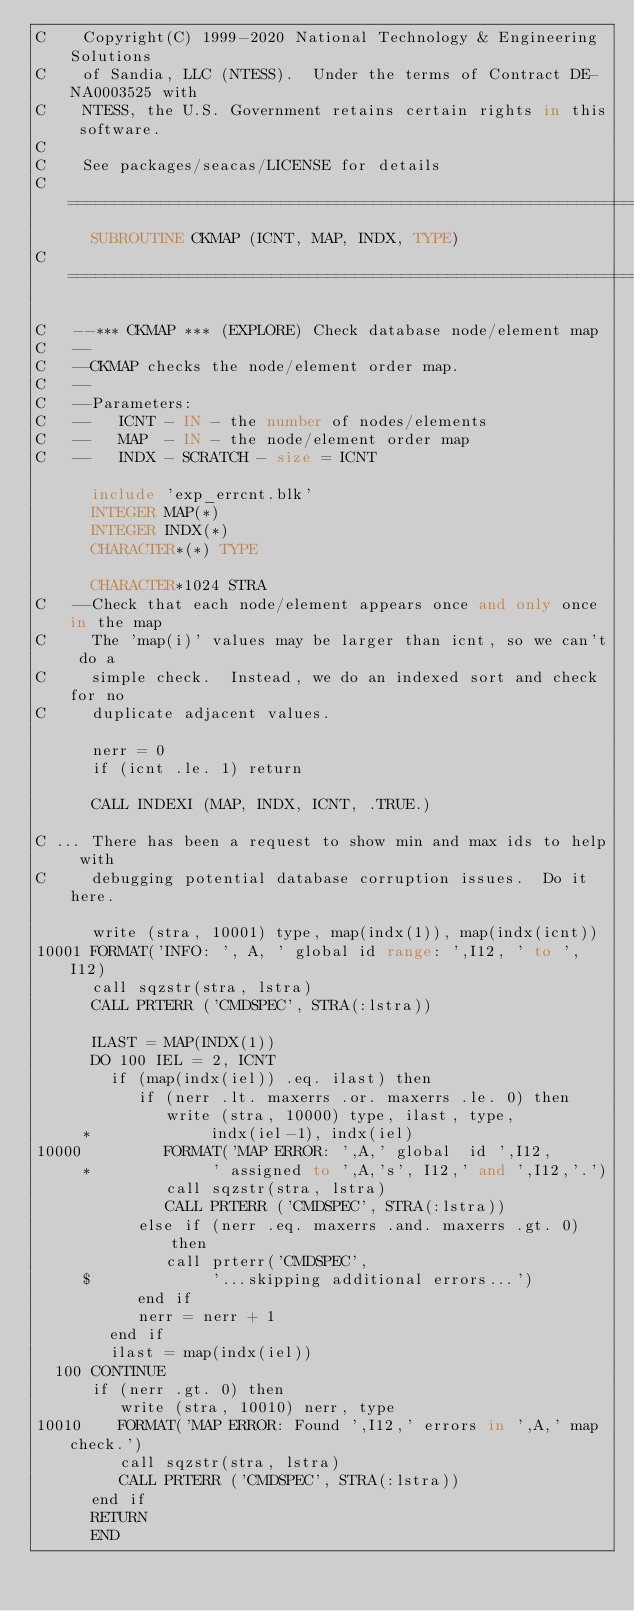<code> <loc_0><loc_0><loc_500><loc_500><_FORTRAN_>C    Copyright(C) 1999-2020 National Technology & Engineering Solutions
C    of Sandia, LLC (NTESS).  Under the terms of Contract DE-NA0003525 with
C    NTESS, the U.S. Government retains certain rights in this software.
C
C    See packages/seacas/LICENSE for details
C=======================================================================
      SUBROUTINE CKMAP (ICNT, MAP, INDX, TYPE)
C=======================================================================

C   --*** CKMAP *** (EXPLORE) Check database node/element map
C   --
C   --CKMAP checks the node/element order map.
C   --
C   --Parameters:
C   --   ICNT - IN - the number of nodes/elements
C   --   MAP  - IN - the node/element order map
C   --   INDX - SCRATCH - size = ICNT

      include 'exp_errcnt.blk'
      INTEGER MAP(*)
      INTEGER INDX(*)
      CHARACTER*(*) TYPE

      CHARACTER*1024 STRA
C   --Check that each node/element appears once and only once in the map
C     The 'map(i)' values may be larger than icnt, so we can't do a
C     simple check.  Instead, we do an indexed sort and check for no
C     duplicate adjacent values.

      nerr = 0
      if (icnt .le. 1) return

      CALL INDEXI (MAP, INDX, ICNT, .TRUE.)

C ... There has been a request to show min and max ids to help with
C     debugging potential database corruption issues.  Do it here.

      write (stra, 10001) type, map(indx(1)), map(indx(icnt))
10001 FORMAT('INFO: ', A, ' global id range: ',I12, ' to ', I12)
      call sqzstr(stra, lstra)
      CALL PRTERR ('CMDSPEC', STRA(:lstra))

      ILAST = MAP(INDX(1))
      DO 100 IEL = 2, ICNT
        if (map(indx(iel)) .eq. ilast) then
           if (nerr .lt. maxerrs .or. maxerrs .le. 0) then
              write (stra, 10000) type, ilast, type,
     *             indx(iel-1), indx(iel)
10000         FORMAT('MAP ERROR: ',A,' global  id ',I12,
     *             ' assigned to ',A,'s', I12,' and ',I12,'.')
              call sqzstr(stra, lstra)
              CALL PRTERR ('CMDSPEC', STRA(:lstra))
           else if (nerr .eq. maxerrs .and. maxerrs .gt. 0) then
              call prterr('CMDSPEC',
     $             '...skipping additional errors...')
           end if
           nerr = nerr + 1
        end if
        ilast = map(indx(iel))
  100 CONTINUE
      if (nerr .gt. 0) then
         write (stra, 10010) nerr, type
10010    FORMAT('MAP ERROR: Found ',I12,' errors in ',A,' map check.')
         call sqzstr(stra, lstra)
         CALL PRTERR ('CMDSPEC', STRA(:lstra))
      end if
      RETURN
      END
</code> 